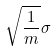Convert formula to latex. <formula><loc_0><loc_0><loc_500><loc_500>\sqrt { \frac { 1 } { m } } \sigma</formula> 